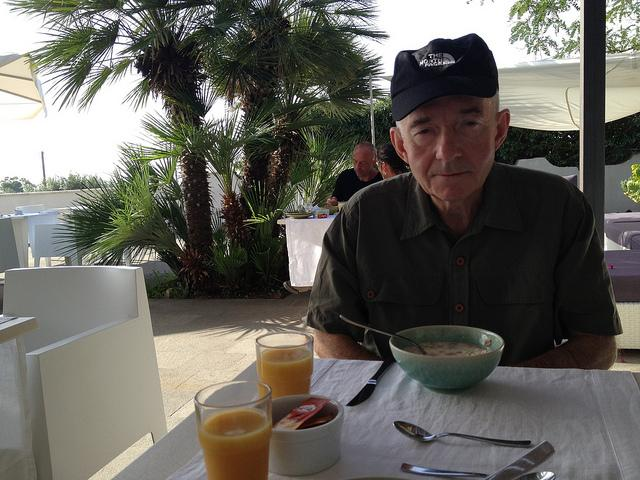What time of day does this man dine here? Please explain your reasoning. morning. He is eating breakfast. 